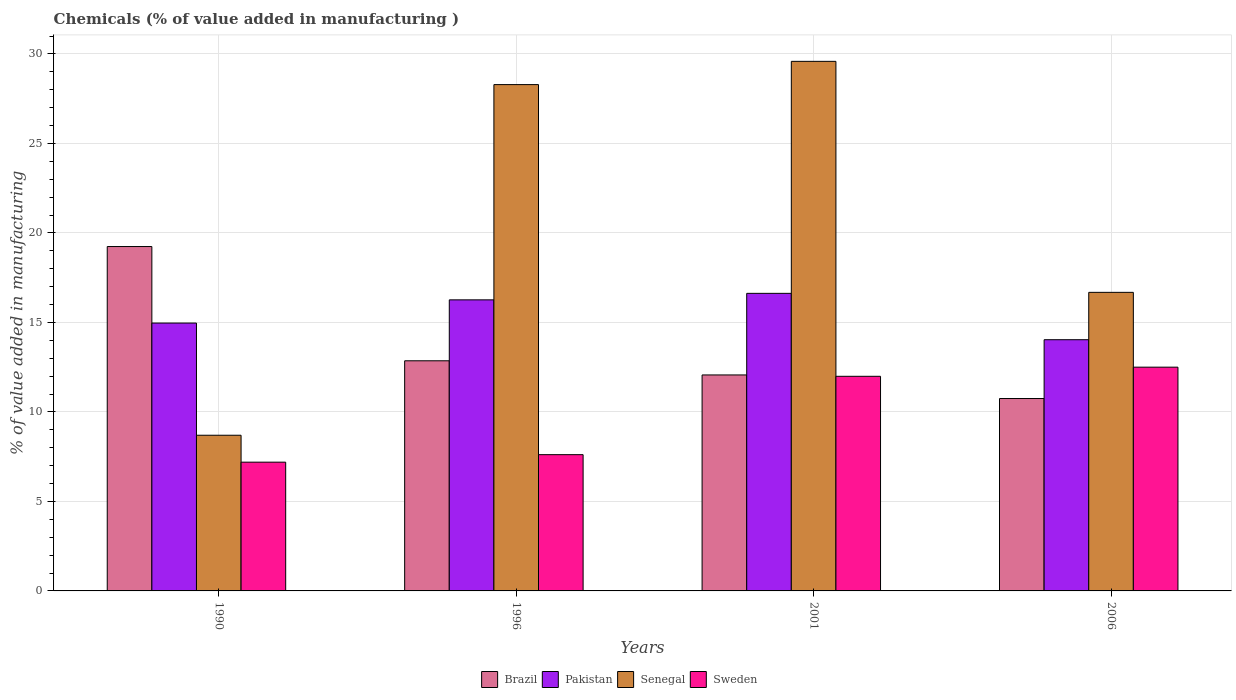How many different coloured bars are there?
Make the answer very short. 4. How many groups of bars are there?
Ensure brevity in your answer.  4. Are the number of bars per tick equal to the number of legend labels?
Offer a very short reply. Yes. Are the number of bars on each tick of the X-axis equal?
Your response must be concise. Yes. How many bars are there on the 2nd tick from the right?
Make the answer very short. 4. What is the label of the 4th group of bars from the left?
Ensure brevity in your answer.  2006. In how many cases, is the number of bars for a given year not equal to the number of legend labels?
Provide a succinct answer. 0. What is the value added in manufacturing chemicals in Sweden in 2001?
Offer a very short reply. 11.99. Across all years, what is the maximum value added in manufacturing chemicals in Brazil?
Your response must be concise. 19.24. Across all years, what is the minimum value added in manufacturing chemicals in Brazil?
Your response must be concise. 10.75. In which year was the value added in manufacturing chemicals in Sweden minimum?
Keep it short and to the point. 1990. What is the total value added in manufacturing chemicals in Sweden in the graph?
Your answer should be very brief. 39.3. What is the difference between the value added in manufacturing chemicals in Brazil in 1996 and that in 2006?
Offer a terse response. 2.11. What is the difference between the value added in manufacturing chemicals in Pakistan in 2001 and the value added in manufacturing chemicals in Sweden in 2006?
Provide a succinct answer. 4.12. What is the average value added in manufacturing chemicals in Pakistan per year?
Your answer should be compact. 15.47. In the year 1996, what is the difference between the value added in manufacturing chemicals in Sweden and value added in manufacturing chemicals in Pakistan?
Keep it short and to the point. -8.65. What is the ratio of the value added in manufacturing chemicals in Brazil in 1990 to that in 2006?
Keep it short and to the point. 1.79. Is the value added in manufacturing chemicals in Senegal in 1996 less than that in 2001?
Offer a terse response. Yes. Is the difference between the value added in manufacturing chemicals in Sweden in 1990 and 2006 greater than the difference between the value added in manufacturing chemicals in Pakistan in 1990 and 2006?
Make the answer very short. No. What is the difference between the highest and the second highest value added in manufacturing chemicals in Sweden?
Offer a terse response. 0.51. What is the difference between the highest and the lowest value added in manufacturing chemicals in Brazil?
Offer a very short reply. 8.49. Is it the case that in every year, the sum of the value added in manufacturing chemicals in Senegal and value added in manufacturing chemicals in Sweden is greater than the value added in manufacturing chemicals in Pakistan?
Offer a terse response. Yes. Are all the bars in the graph horizontal?
Offer a terse response. No. What is the difference between two consecutive major ticks on the Y-axis?
Keep it short and to the point. 5. Does the graph contain grids?
Your answer should be compact. Yes. How many legend labels are there?
Offer a terse response. 4. How are the legend labels stacked?
Offer a very short reply. Horizontal. What is the title of the graph?
Make the answer very short. Chemicals (% of value added in manufacturing ). What is the label or title of the Y-axis?
Provide a succinct answer. % of value added in manufacturing. What is the % of value added in manufacturing in Brazil in 1990?
Provide a short and direct response. 19.24. What is the % of value added in manufacturing of Pakistan in 1990?
Your answer should be compact. 14.97. What is the % of value added in manufacturing of Senegal in 1990?
Ensure brevity in your answer.  8.7. What is the % of value added in manufacturing in Sweden in 1990?
Your response must be concise. 7.19. What is the % of value added in manufacturing in Brazil in 1996?
Provide a short and direct response. 12.86. What is the % of value added in manufacturing in Pakistan in 1996?
Make the answer very short. 16.26. What is the % of value added in manufacturing in Senegal in 1996?
Your answer should be very brief. 28.29. What is the % of value added in manufacturing of Sweden in 1996?
Your response must be concise. 7.61. What is the % of value added in manufacturing in Brazil in 2001?
Give a very brief answer. 12.07. What is the % of value added in manufacturing in Pakistan in 2001?
Keep it short and to the point. 16.62. What is the % of value added in manufacturing of Senegal in 2001?
Your answer should be very brief. 29.59. What is the % of value added in manufacturing of Sweden in 2001?
Keep it short and to the point. 11.99. What is the % of value added in manufacturing of Brazil in 2006?
Keep it short and to the point. 10.75. What is the % of value added in manufacturing of Pakistan in 2006?
Keep it short and to the point. 14.03. What is the % of value added in manufacturing of Senegal in 2006?
Provide a short and direct response. 16.68. What is the % of value added in manufacturing of Sweden in 2006?
Offer a terse response. 12.5. Across all years, what is the maximum % of value added in manufacturing in Brazil?
Offer a very short reply. 19.24. Across all years, what is the maximum % of value added in manufacturing in Pakistan?
Offer a very short reply. 16.62. Across all years, what is the maximum % of value added in manufacturing in Senegal?
Provide a succinct answer. 29.59. Across all years, what is the maximum % of value added in manufacturing of Sweden?
Offer a very short reply. 12.5. Across all years, what is the minimum % of value added in manufacturing in Brazil?
Your answer should be compact. 10.75. Across all years, what is the minimum % of value added in manufacturing in Pakistan?
Your answer should be very brief. 14.03. Across all years, what is the minimum % of value added in manufacturing in Senegal?
Your response must be concise. 8.7. Across all years, what is the minimum % of value added in manufacturing in Sweden?
Offer a terse response. 7.19. What is the total % of value added in manufacturing in Brazil in the graph?
Ensure brevity in your answer.  54.91. What is the total % of value added in manufacturing of Pakistan in the graph?
Ensure brevity in your answer.  61.89. What is the total % of value added in manufacturing in Senegal in the graph?
Your response must be concise. 83.25. What is the total % of value added in manufacturing in Sweden in the graph?
Your answer should be compact. 39.3. What is the difference between the % of value added in manufacturing in Brazil in 1990 and that in 1996?
Your response must be concise. 6.38. What is the difference between the % of value added in manufacturing of Pakistan in 1990 and that in 1996?
Provide a succinct answer. -1.3. What is the difference between the % of value added in manufacturing of Senegal in 1990 and that in 1996?
Give a very brief answer. -19.59. What is the difference between the % of value added in manufacturing of Sweden in 1990 and that in 1996?
Your answer should be compact. -0.42. What is the difference between the % of value added in manufacturing in Brazil in 1990 and that in 2001?
Your answer should be very brief. 7.17. What is the difference between the % of value added in manufacturing in Pakistan in 1990 and that in 2001?
Your answer should be very brief. -1.66. What is the difference between the % of value added in manufacturing of Senegal in 1990 and that in 2001?
Provide a succinct answer. -20.89. What is the difference between the % of value added in manufacturing in Sweden in 1990 and that in 2001?
Your answer should be compact. -4.8. What is the difference between the % of value added in manufacturing in Brazil in 1990 and that in 2006?
Your answer should be very brief. 8.49. What is the difference between the % of value added in manufacturing in Pakistan in 1990 and that in 2006?
Make the answer very short. 0.93. What is the difference between the % of value added in manufacturing of Senegal in 1990 and that in 2006?
Provide a succinct answer. -7.98. What is the difference between the % of value added in manufacturing of Sweden in 1990 and that in 2006?
Ensure brevity in your answer.  -5.31. What is the difference between the % of value added in manufacturing in Brazil in 1996 and that in 2001?
Keep it short and to the point. 0.79. What is the difference between the % of value added in manufacturing in Pakistan in 1996 and that in 2001?
Offer a very short reply. -0.36. What is the difference between the % of value added in manufacturing of Senegal in 1996 and that in 2001?
Provide a short and direct response. -1.3. What is the difference between the % of value added in manufacturing in Sweden in 1996 and that in 2001?
Ensure brevity in your answer.  -4.38. What is the difference between the % of value added in manufacturing in Brazil in 1996 and that in 2006?
Your response must be concise. 2.11. What is the difference between the % of value added in manufacturing of Pakistan in 1996 and that in 2006?
Your answer should be compact. 2.23. What is the difference between the % of value added in manufacturing of Senegal in 1996 and that in 2006?
Offer a terse response. 11.61. What is the difference between the % of value added in manufacturing in Sweden in 1996 and that in 2006?
Ensure brevity in your answer.  -4.89. What is the difference between the % of value added in manufacturing in Brazil in 2001 and that in 2006?
Your response must be concise. 1.32. What is the difference between the % of value added in manufacturing of Pakistan in 2001 and that in 2006?
Ensure brevity in your answer.  2.59. What is the difference between the % of value added in manufacturing in Senegal in 2001 and that in 2006?
Provide a succinct answer. 12.91. What is the difference between the % of value added in manufacturing of Sweden in 2001 and that in 2006?
Your answer should be compact. -0.51. What is the difference between the % of value added in manufacturing in Brazil in 1990 and the % of value added in manufacturing in Pakistan in 1996?
Your response must be concise. 2.98. What is the difference between the % of value added in manufacturing in Brazil in 1990 and the % of value added in manufacturing in Senegal in 1996?
Keep it short and to the point. -9.05. What is the difference between the % of value added in manufacturing of Brazil in 1990 and the % of value added in manufacturing of Sweden in 1996?
Give a very brief answer. 11.63. What is the difference between the % of value added in manufacturing of Pakistan in 1990 and the % of value added in manufacturing of Senegal in 1996?
Keep it short and to the point. -13.32. What is the difference between the % of value added in manufacturing in Pakistan in 1990 and the % of value added in manufacturing in Sweden in 1996?
Give a very brief answer. 7.35. What is the difference between the % of value added in manufacturing in Senegal in 1990 and the % of value added in manufacturing in Sweden in 1996?
Your response must be concise. 1.08. What is the difference between the % of value added in manufacturing in Brazil in 1990 and the % of value added in manufacturing in Pakistan in 2001?
Your response must be concise. 2.62. What is the difference between the % of value added in manufacturing of Brazil in 1990 and the % of value added in manufacturing of Senegal in 2001?
Offer a very short reply. -10.35. What is the difference between the % of value added in manufacturing in Brazil in 1990 and the % of value added in manufacturing in Sweden in 2001?
Ensure brevity in your answer.  7.25. What is the difference between the % of value added in manufacturing of Pakistan in 1990 and the % of value added in manufacturing of Senegal in 2001?
Provide a succinct answer. -14.62. What is the difference between the % of value added in manufacturing in Pakistan in 1990 and the % of value added in manufacturing in Sweden in 2001?
Keep it short and to the point. 2.98. What is the difference between the % of value added in manufacturing of Senegal in 1990 and the % of value added in manufacturing of Sweden in 2001?
Your response must be concise. -3.29. What is the difference between the % of value added in manufacturing in Brazil in 1990 and the % of value added in manufacturing in Pakistan in 2006?
Give a very brief answer. 5.2. What is the difference between the % of value added in manufacturing of Brazil in 1990 and the % of value added in manufacturing of Senegal in 2006?
Your answer should be very brief. 2.56. What is the difference between the % of value added in manufacturing in Brazil in 1990 and the % of value added in manufacturing in Sweden in 2006?
Your response must be concise. 6.74. What is the difference between the % of value added in manufacturing in Pakistan in 1990 and the % of value added in manufacturing in Senegal in 2006?
Provide a succinct answer. -1.71. What is the difference between the % of value added in manufacturing in Pakistan in 1990 and the % of value added in manufacturing in Sweden in 2006?
Your answer should be very brief. 2.46. What is the difference between the % of value added in manufacturing in Senegal in 1990 and the % of value added in manufacturing in Sweden in 2006?
Your answer should be compact. -3.8. What is the difference between the % of value added in manufacturing in Brazil in 1996 and the % of value added in manufacturing in Pakistan in 2001?
Make the answer very short. -3.77. What is the difference between the % of value added in manufacturing in Brazil in 1996 and the % of value added in manufacturing in Senegal in 2001?
Give a very brief answer. -16.73. What is the difference between the % of value added in manufacturing of Brazil in 1996 and the % of value added in manufacturing of Sweden in 2001?
Make the answer very short. 0.87. What is the difference between the % of value added in manufacturing of Pakistan in 1996 and the % of value added in manufacturing of Senegal in 2001?
Keep it short and to the point. -13.32. What is the difference between the % of value added in manufacturing of Pakistan in 1996 and the % of value added in manufacturing of Sweden in 2001?
Your response must be concise. 4.27. What is the difference between the % of value added in manufacturing in Senegal in 1996 and the % of value added in manufacturing in Sweden in 2001?
Make the answer very short. 16.3. What is the difference between the % of value added in manufacturing in Brazil in 1996 and the % of value added in manufacturing in Pakistan in 2006?
Provide a short and direct response. -1.18. What is the difference between the % of value added in manufacturing in Brazil in 1996 and the % of value added in manufacturing in Senegal in 2006?
Provide a succinct answer. -3.82. What is the difference between the % of value added in manufacturing in Brazil in 1996 and the % of value added in manufacturing in Sweden in 2006?
Your answer should be compact. 0.36. What is the difference between the % of value added in manufacturing in Pakistan in 1996 and the % of value added in manufacturing in Senegal in 2006?
Your answer should be very brief. -0.42. What is the difference between the % of value added in manufacturing in Pakistan in 1996 and the % of value added in manufacturing in Sweden in 2006?
Make the answer very short. 3.76. What is the difference between the % of value added in manufacturing in Senegal in 1996 and the % of value added in manufacturing in Sweden in 2006?
Offer a terse response. 15.79. What is the difference between the % of value added in manufacturing in Brazil in 2001 and the % of value added in manufacturing in Pakistan in 2006?
Keep it short and to the point. -1.97. What is the difference between the % of value added in manufacturing of Brazil in 2001 and the % of value added in manufacturing of Senegal in 2006?
Offer a terse response. -4.61. What is the difference between the % of value added in manufacturing of Brazil in 2001 and the % of value added in manufacturing of Sweden in 2006?
Your answer should be compact. -0.43. What is the difference between the % of value added in manufacturing of Pakistan in 2001 and the % of value added in manufacturing of Senegal in 2006?
Your response must be concise. -0.06. What is the difference between the % of value added in manufacturing in Pakistan in 2001 and the % of value added in manufacturing in Sweden in 2006?
Your answer should be very brief. 4.12. What is the difference between the % of value added in manufacturing of Senegal in 2001 and the % of value added in manufacturing of Sweden in 2006?
Make the answer very short. 17.09. What is the average % of value added in manufacturing in Brazil per year?
Your answer should be very brief. 13.73. What is the average % of value added in manufacturing of Pakistan per year?
Offer a very short reply. 15.47. What is the average % of value added in manufacturing in Senegal per year?
Ensure brevity in your answer.  20.81. What is the average % of value added in manufacturing in Sweden per year?
Ensure brevity in your answer.  9.82. In the year 1990, what is the difference between the % of value added in manufacturing in Brazil and % of value added in manufacturing in Pakistan?
Provide a succinct answer. 4.27. In the year 1990, what is the difference between the % of value added in manufacturing in Brazil and % of value added in manufacturing in Senegal?
Offer a terse response. 10.54. In the year 1990, what is the difference between the % of value added in manufacturing in Brazil and % of value added in manufacturing in Sweden?
Offer a very short reply. 12.05. In the year 1990, what is the difference between the % of value added in manufacturing in Pakistan and % of value added in manufacturing in Senegal?
Offer a very short reply. 6.27. In the year 1990, what is the difference between the % of value added in manufacturing in Pakistan and % of value added in manufacturing in Sweden?
Give a very brief answer. 7.77. In the year 1990, what is the difference between the % of value added in manufacturing in Senegal and % of value added in manufacturing in Sweden?
Keep it short and to the point. 1.5. In the year 1996, what is the difference between the % of value added in manufacturing in Brazil and % of value added in manufacturing in Pakistan?
Your response must be concise. -3.4. In the year 1996, what is the difference between the % of value added in manufacturing of Brazil and % of value added in manufacturing of Senegal?
Give a very brief answer. -15.43. In the year 1996, what is the difference between the % of value added in manufacturing of Brazil and % of value added in manufacturing of Sweden?
Your answer should be compact. 5.24. In the year 1996, what is the difference between the % of value added in manufacturing in Pakistan and % of value added in manufacturing in Senegal?
Give a very brief answer. -12.03. In the year 1996, what is the difference between the % of value added in manufacturing in Pakistan and % of value added in manufacturing in Sweden?
Offer a terse response. 8.65. In the year 1996, what is the difference between the % of value added in manufacturing in Senegal and % of value added in manufacturing in Sweden?
Make the answer very short. 20.68. In the year 2001, what is the difference between the % of value added in manufacturing of Brazil and % of value added in manufacturing of Pakistan?
Offer a terse response. -4.56. In the year 2001, what is the difference between the % of value added in manufacturing in Brazil and % of value added in manufacturing in Senegal?
Your response must be concise. -17.52. In the year 2001, what is the difference between the % of value added in manufacturing in Brazil and % of value added in manufacturing in Sweden?
Your response must be concise. 0.08. In the year 2001, what is the difference between the % of value added in manufacturing in Pakistan and % of value added in manufacturing in Senegal?
Provide a succinct answer. -12.96. In the year 2001, what is the difference between the % of value added in manufacturing in Pakistan and % of value added in manufacturing in Sweden?
Offer a very short reply. 4.63. In the year 2001, what is the difference between the % of value added in manufacturing in Senegal and % of value added in manufacturing in Sweden?
Make the answer very short. 17.6. In the year 2006, what is the difference between the % of value added in manufacturing in Brazil and % of value added in manufacturing in Pakistan?
Provide a succinct answer. -3.29. In the year 2006, what is the difference between the % of value added in manufacturing of Brazil and % of value added in manufacturing of Senegal?
Keep it short and to the point. -5.93. In the year 2006, what is the difference between the % of value added in manufacturing in Brazil and % of value added in manufacturing in Sweden?
Your answer should be very brief. -1.75. In the year 2006, what is the difference between the % of value added in manufacturing of Pakistan and % of value added in manufacturing of Senegal?
Offer a terse response. -2.65. In the year 2006, what is the difference between the % of value added in manufacturing in Pakistan and % of value added in manufacturing in Sweden?
Your response must be concise. 1.53. In the year 2006, what is the difference between the % of value added in manufacturing in Senegal and % of value added in manufacturing in Sweden?
Ensure brevity in your answer.  4.18. What is the ratio of the % of value added in manufacturing of Brazil in 1990 to that in 1996?
Give a very brief answer. 1.5. What is the ratio of the % of value added in manufacturing of Pakistan in 1990 to that in 1996?
Keep it short and to the point. 0.92. What is the ratio of the % of value added in manufacturing of Senegal in 1990 to that in 1996?
Provide a succinct answer. 0.31. What is the ratio of the % of value added in manufacturing of Sweden in 1990 to that in 1996?
Offer a very short reply. 0.94. What is the ratio of the % of value added in manufacturing of Brazil in 1990 to that in 2001?
Give a very brief answer. 1.59. What is the ratio of the % of value added in manufacturing of Pakistan in 1990 to that in 2001?
Provide a short and direct response. 0.9. What is the ratio of the % of value added in manufacturing in Senegal in 1990 to that in 2001?
Offer a very short reply. 0.29. What is the ratio of the % of value added in manufacturing in Sweden in 1990 to that in 2001?
Offer a terse response. 0.6. What is the ratio of the % of value added in manufacturing in Brazil in 1990 to that in 2006?
Provide a succinct answer. 1.79. What is the ratio of the % of value added in manufacturing of Pakistan in 1990 to that in 2006?
Give a very brief answer. 1.07. What is the ratio of the % of value added in manufacturing of Senegal in 1990 to that in 2006?
Provide a short and direct response. 0.52. What is the ratio of the % of value added in manufacturing of Sweden in 1990 to that in 2006?
Offer a terse response. 0.58. What is the ratio of the % of value added in manufacturing of Brazil in 1996 to that in 2001?
Provide a short and direct response. 1.07. What is the ratio of the % of value added in manufacturing in Pakistan in 1996 to that in 2001?
Your response must be concise. 0.98. What is the ratio of the % of value added in manufacturing in Senegal in 1996 to that in 2001?
Ensure brevity in your answer.  0.96. What is the ratio of the % of value added in manufacturing in Sweden in 1996 to that in 2001?
Give a very brief answer. 0.63. What is the ratio of the % of value added in manufacturing in Brazil in 1996 to that in 2006?
Offer a very short reply. 1.2. What is the ratio of the % of value added in manufacturing in Pakistan in 1996 to that in 2006?
Offer a terse response. 1.16. What is the ratio of the % of value added in manufacturing of Senegal in 1996 to that in 2006?
Your answer should be very brief. 1.7. What is the ratio of the % of value added in manufacturing in Sweden in 1996 to that in 2006?
Give a very brief answer. 0.61. What is the ratio of the % of value added in manufacturing of Brazil in 2001 to that in 2006?
Provide a short and direct response. 1.12. What is the ratio of the % of value added in manufacturing of Pakistan in 2001 to that in 2006?
Keep it short and to the point. 1.18. What is the ratio of the % of value added in manufacturing of Senegal in 2001 to that in 2006?
Give a very brief answer. 1.77. What is the ratio of the % of value added in manufacturing of Sweden in 2001 to that in 2006?
Provide a short and direct response. 0.96. What is the difference between the highest and the second highest % of value added in manufacturing of Brazil?
Make the answer very short. 6.38. What is the difference between the highest and the second highest % of value added in manufacturing in Pakistan?
Your response must be concise. 0.36. What is the difference between the highest and the second highest % of value added in manufacturing in Senegal?
Your answer should be compact. 1.3. What is the difference between the highest and the second highest % of value added in manufacturing in Sweden?
Provide a succinct answer. 0.51. What is the difference between the highest and the lowest % of value added in manufacturing in Brazil?
Give a very brief answer. 8.49. What is the difference between the highest and the lowest % of value added in manufacturing of Pakistan?
Offer a very short reply. 2.59. What is the difference between the highest and the lowest % of value added in manufacturing in Senegal?
Offer a terse response. 20.89. What is the difference between the highest and the lowest % of value added in manufacturing of Sweden?
Make the answer very short. 5.31. 